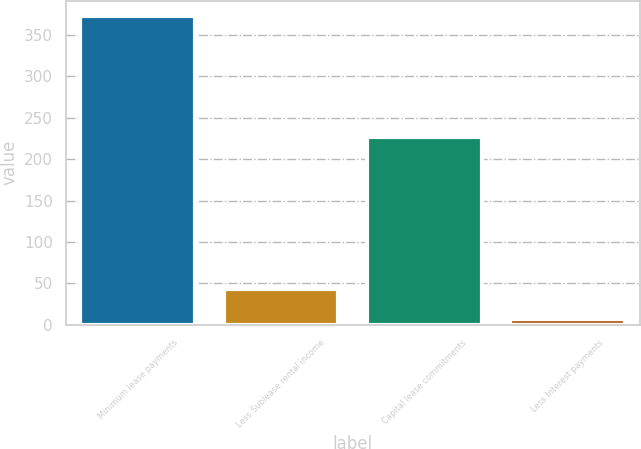Convert chart. <chart><loc_0><loc_0><loc_500><loc_500><bar_chart><fcel>Minimum lease payments<fcel>Less Sublease rental income<fcel>Capital lease commitments<fcel>Less Interest payments<nl><fcel>373<fcel>43.6<fcel>227<fcel>7<nl></chart> 